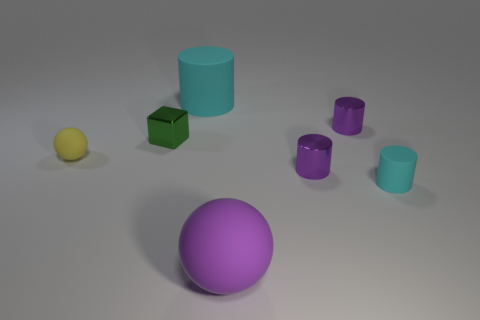What color is the shiny cube?
Keep it short and to the point. Green. Is there a matte cylinder behind the rubber cylinder that is in front of the yellow ball?
Your answer should be compact. Yes. What number of matte spheres are the same size as the yellow object?
Provide a succinct answer. 0. There is a cyan cylinder left of the small cyan matte object that is behind the purple rubber ball; what number of purple spheres are behind it?
Provide a short and direct response. 0. What number of large rubber objects are in front of the tiny matte cylinder and left of the big purple matte object?
Give a very brief answer. 0. Is there any other thing that has the same color as the large cylinder?
Ensure brevity in your answer.  Yes. How many metal things are either big cylinders or purple things?
Offer a terse response. 2. There is a cyan object that is right of the cyan rubber thing behind the matte cylinder that is right of the big cyan thing; what is it made of?
Provide a succinct answer. Rubber. What material is the cyan cylinder behind the cyan object to the right of the purple ball?
Ensure brevity in your answer.  Rubber. Does the sphere that is left of the large rubber sphere have the same size as the matte object behind the shiny cube?
Provide a succinct answer. No. 